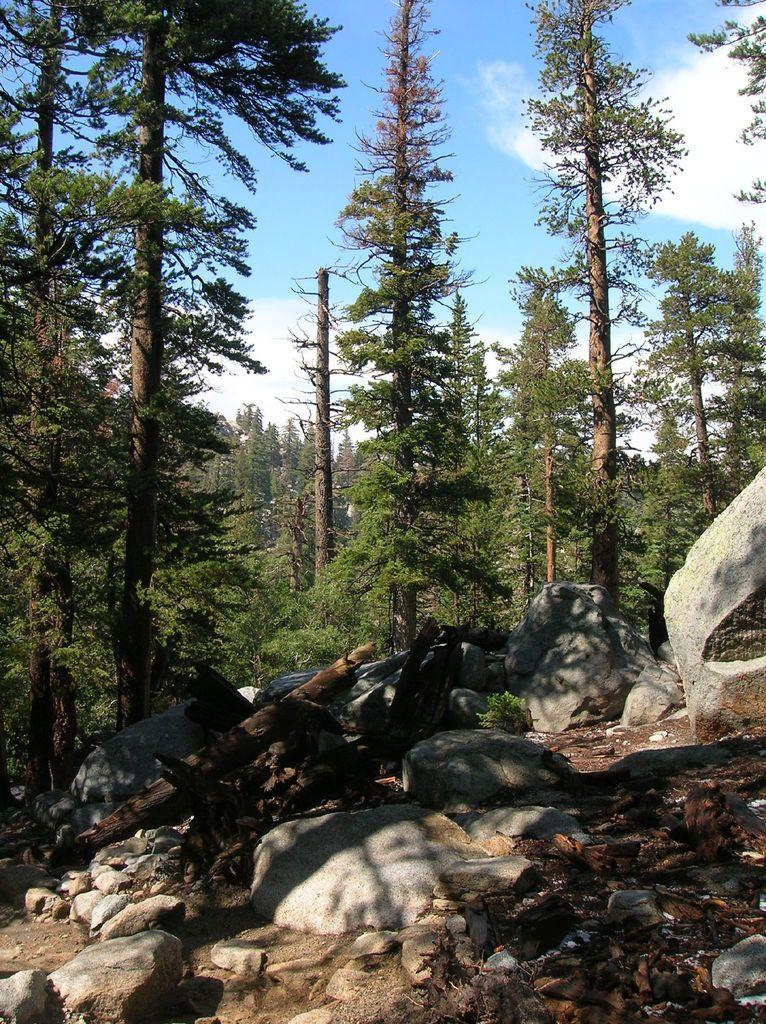What type of natural objects can be seen in the image? There are rocks, logs, and trees in the image. What is visible in the sky at the top of the image? There are clouds visible in the sky at the top of the image. Can you see a cat playing with a band in the image? There is no cat or band present in the image. What type of tongue can be seen sticking out of the tree in the image? There is no tongue visible in the image, as it features rocks, logs, trees, and clouds in the sky. 